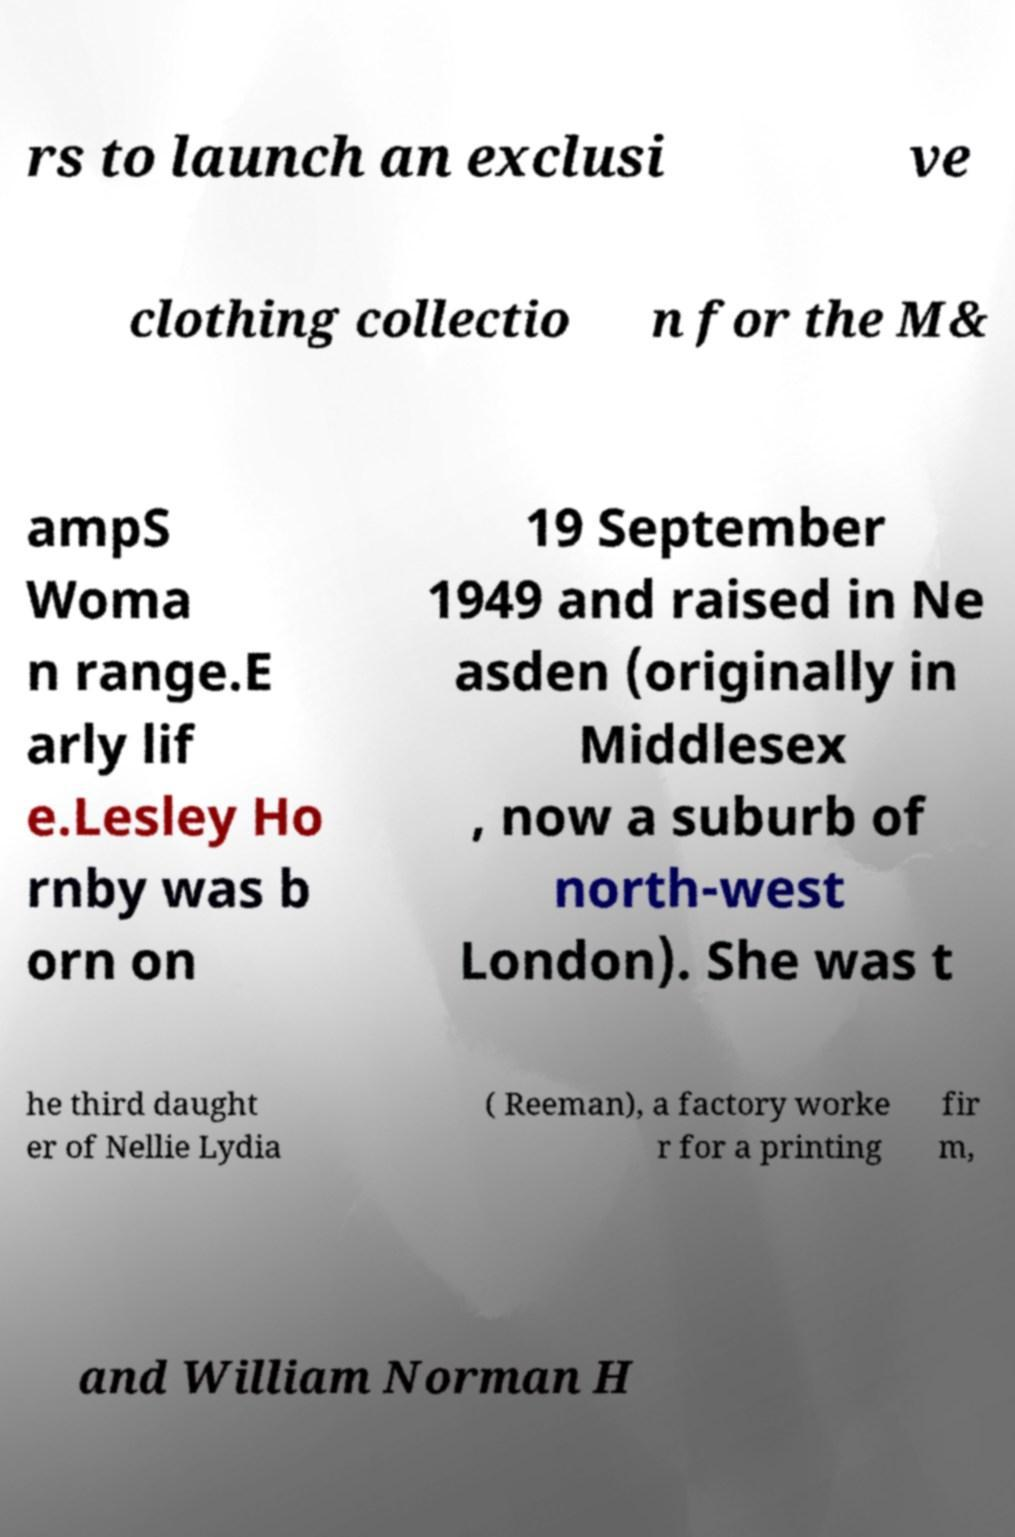Could you extract and type out the text from this image? rs to launch an exclusi ve clothing collectio n for the M& ampS Woma n range.E arly lif e.Lesley Ho rnby was b orn on 19 September 1949 and raised in Ne asden (originally in Middlesex , now a suburb of north-west London). She was t he third daught er of Nellie Lydia ( Reeman), a factory worke r for a printing fir m, and William Norman H 